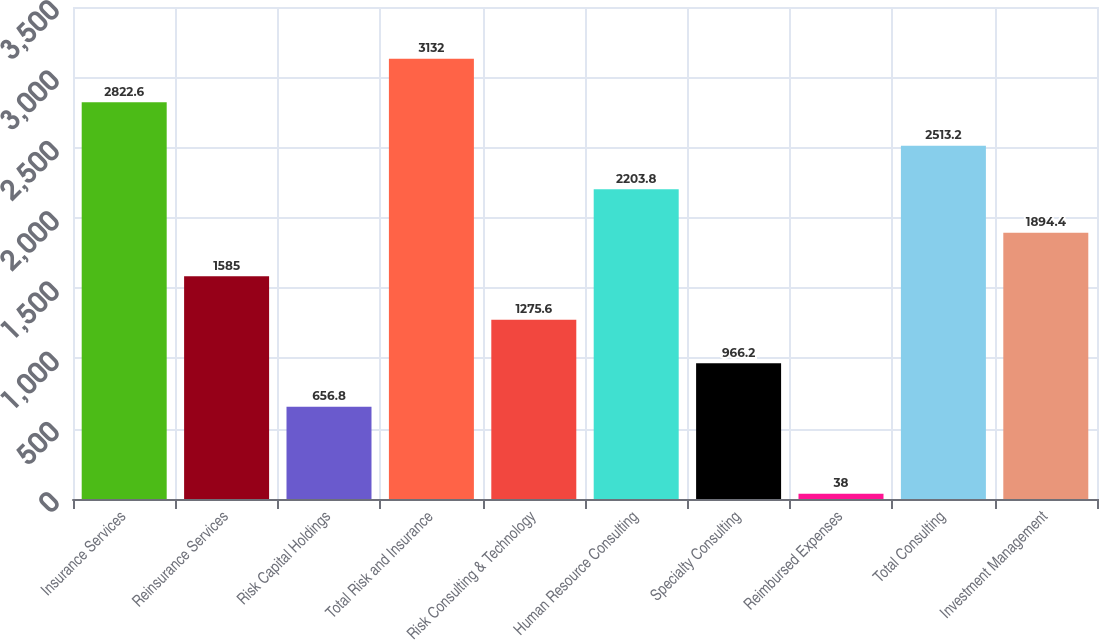Convert chart to OTSL. <chart><loc_0><loc_0><loc_500><loc_500><bar_chart><fcel>Insurance Services<fcel>Reinsurance Services<fcel>Risk Capital Holdings<fcel>Total Risk and Insurance<fcel>Risk Consulting & Technology<fcel>Human Resource Consulting<fcel>Specialty Consulting<fcel>Reimbursed Expenses<fcel>Total Consulting<fcel>Investment Management<nl><fcel>2822.6<fcel>1585<fcel>656.8<fcel>3132<fcel>1275.6<fcel>2203.8<fcel>966.2<fcel>38<fcel>2513.2<fcel>1894.4<nl></chart> 